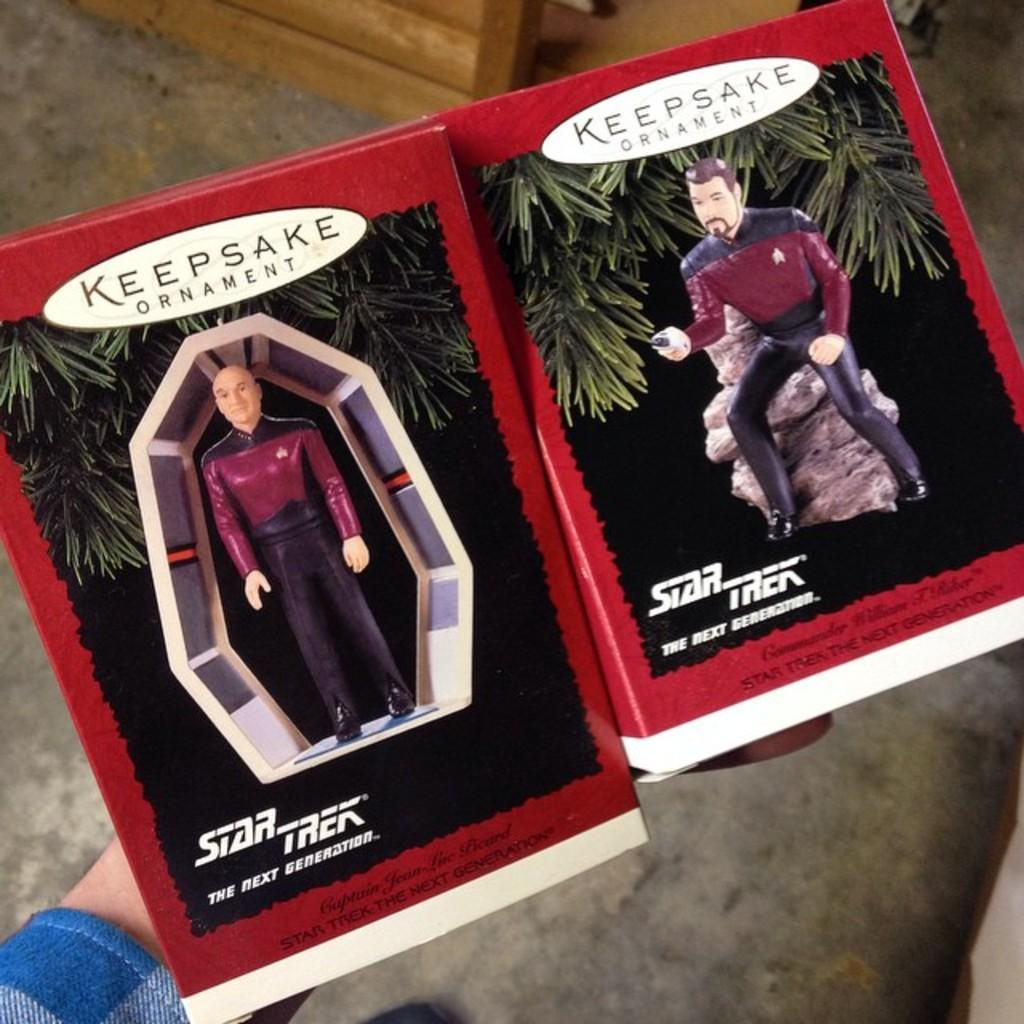What is the main subject in the center of the image? There are books in the center of the image. Who is interacting with the books in the image? A person is holding the books. What can be seen in the background of the image? There is a floor visible in the background of the image. What is located at the top of the image? There is an object at the top of the image. What type of soup is being prepared by the grandfather in the image? There is no grandfather or soup present in the image. 